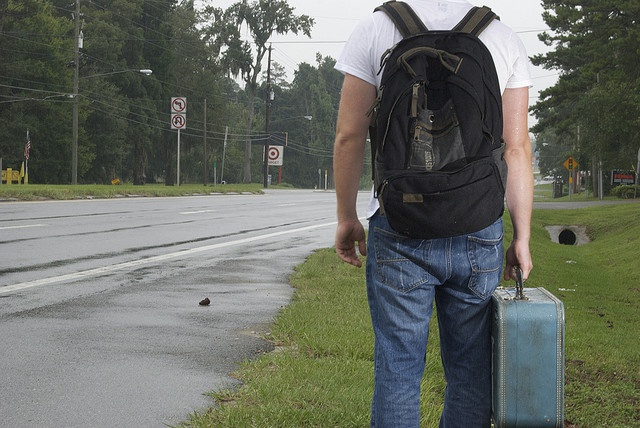Describe the objects in this image and their specific colors. I can see people in black, gray, and lightgray tones, backpack in black and gray tones, and suitcase in black, gray, and darkgray tones in this image. 